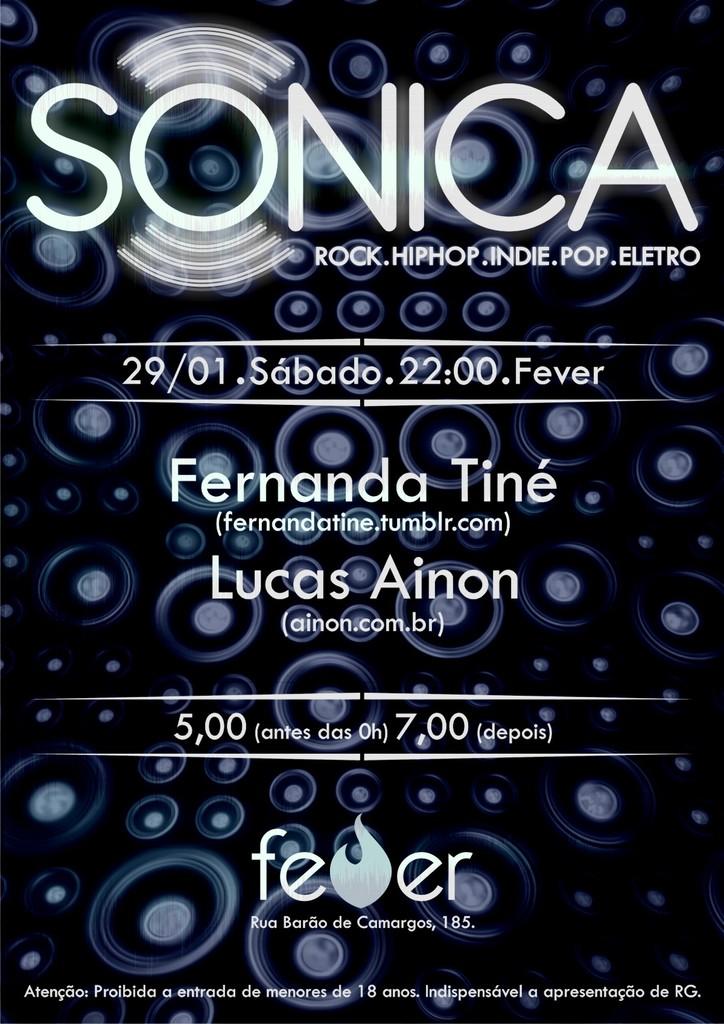What drink is being advertised?
Offer a terse response. Unanswerable. What is the name of this event?
Your answer should be very brief. Sonica. 